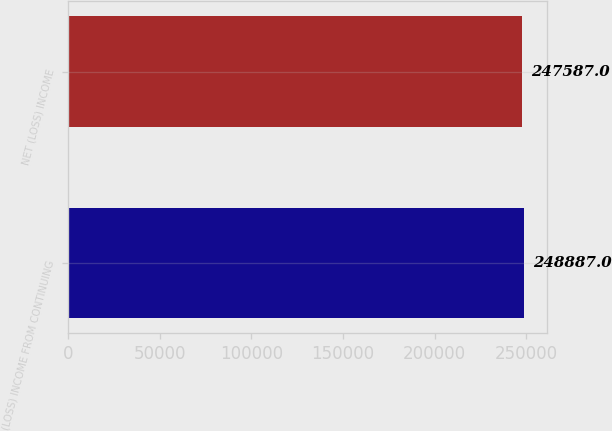Convert chart. <chart><loc_0><loc_0><loc_500><loc_500><bar_chart><fcel>(LOSS) INCOME FROM CONTINUING<fcel>NET (LOSS) INCOME<nl><fcel>248887<fcel>247587<nl></chart> 